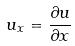<formula> <loc_0><loc_0><loc_500><loc_500>u _ { x } = \frac { \partial u } { \partial x }</formula> 